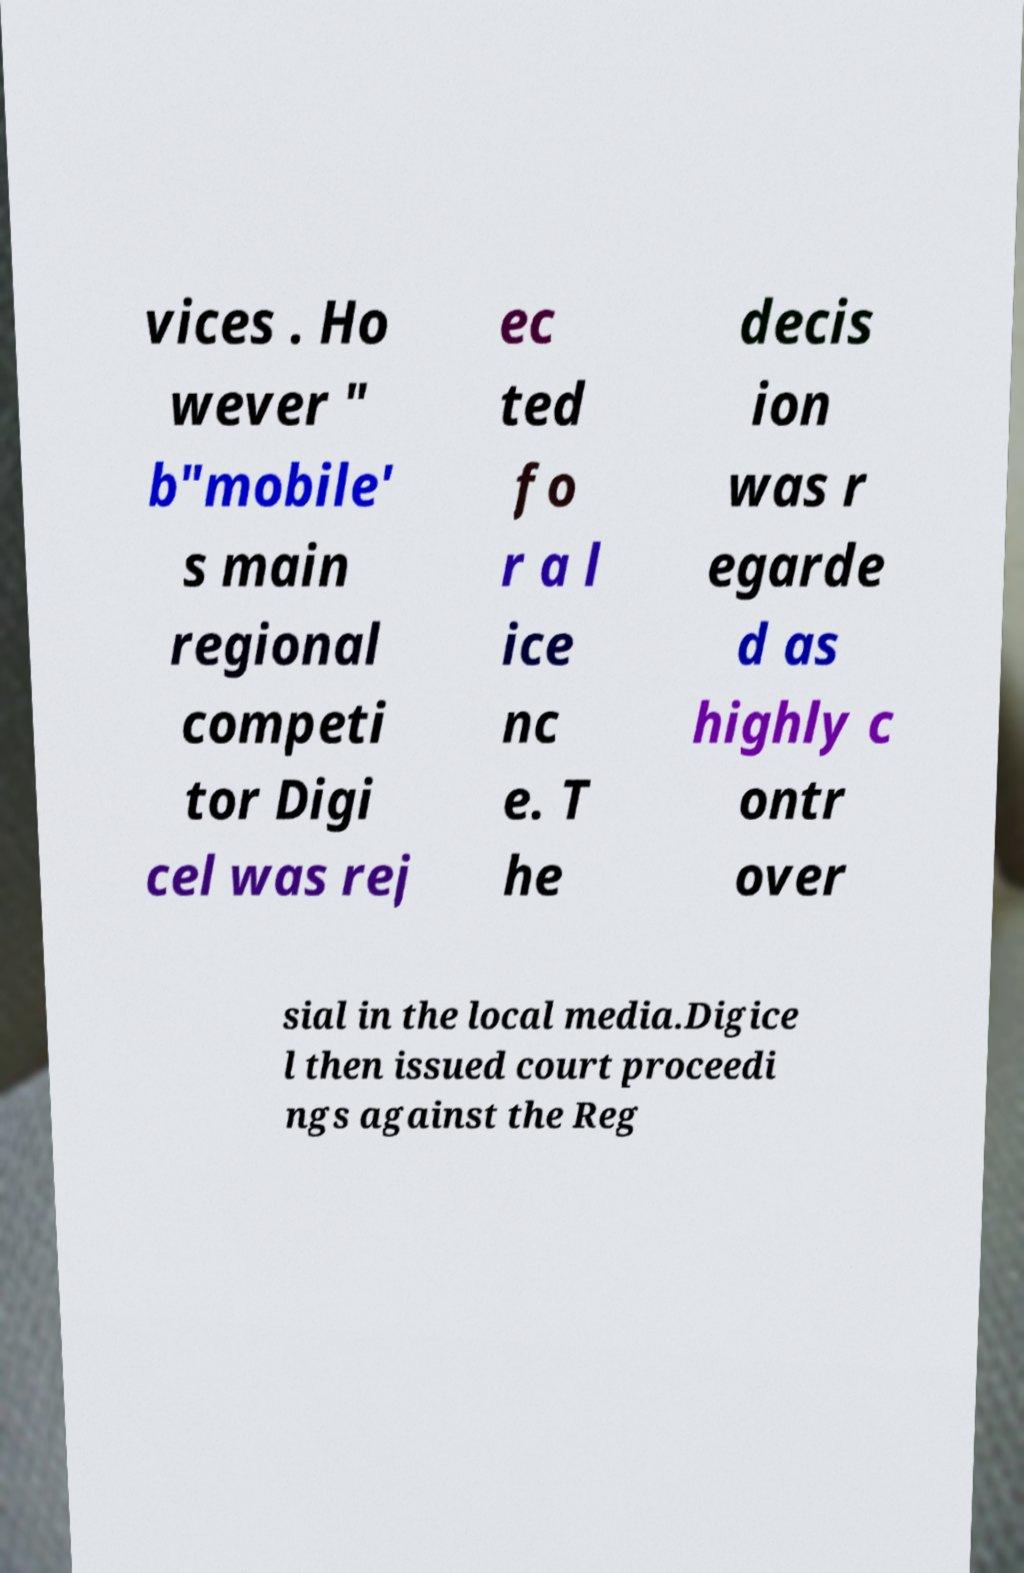What messages or text are displayed in this image? I need them in a readable, typed format. vices . Ho wever " b"mobile' s main regional competi tor Digi cel was rej ec ted fo r a l ice nc e. T he decis ion was r egarde d as highly c ontr over sial in the local media.Digice l then issued court proceedi ngs against the Reg 